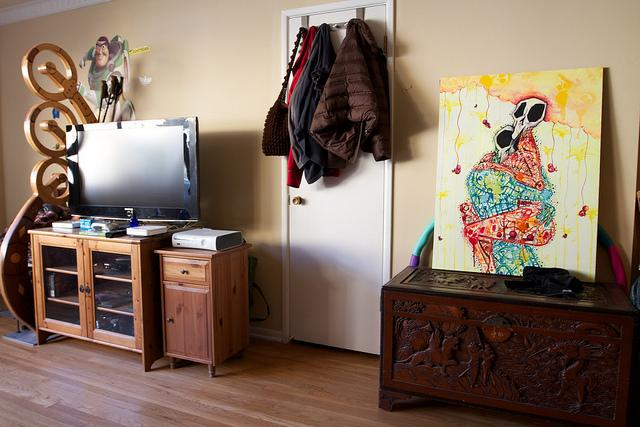What color is the coat jacket on the right side of the rack hung on the white door? brown 